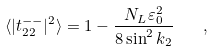<formula> <loc_0><loc_0><loc_500><loc_500>\langle | t ^ { - - } _ { 2 2 } | ^ { 2 } \rangle = 1 - \frac { N _ { L } \varepsilon ^ { 2 } _ { 0 } } { 8 \sin ^ { 2 } k _ { 2 } } \quad ,</formula> 